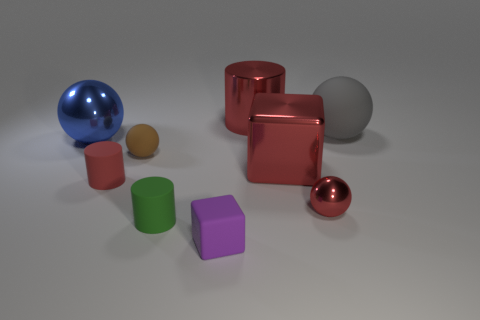Add 1 red matte blocks. How many objects exist? 10 Subtract all spheres. How many objects are left? 5 Subtract 0 yellow balls. How many objects are left? 9 Subtract all tiny brown objects. Subtract all tiny purple rubber objects. How many objects are left? 7 Add 9 small red cylinders. How many small red cylinders are left? 10 Add 2 purple cylinders. How many purple cylinders exist? 2 